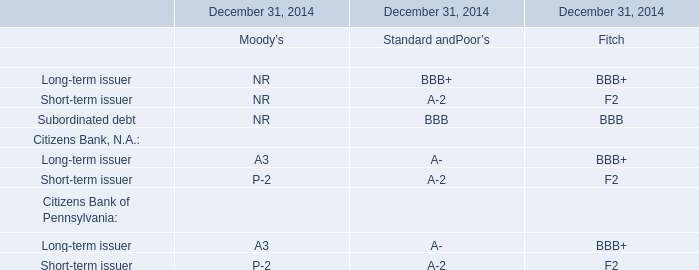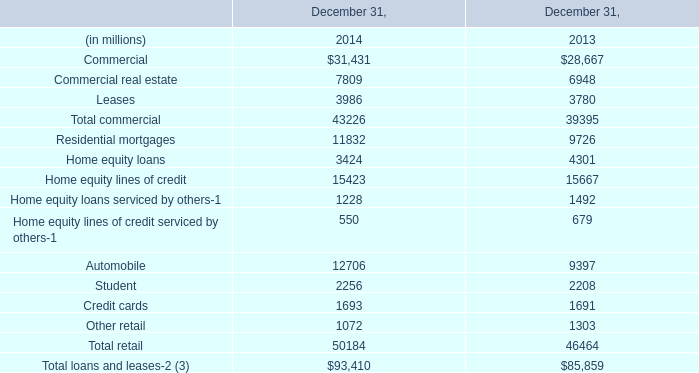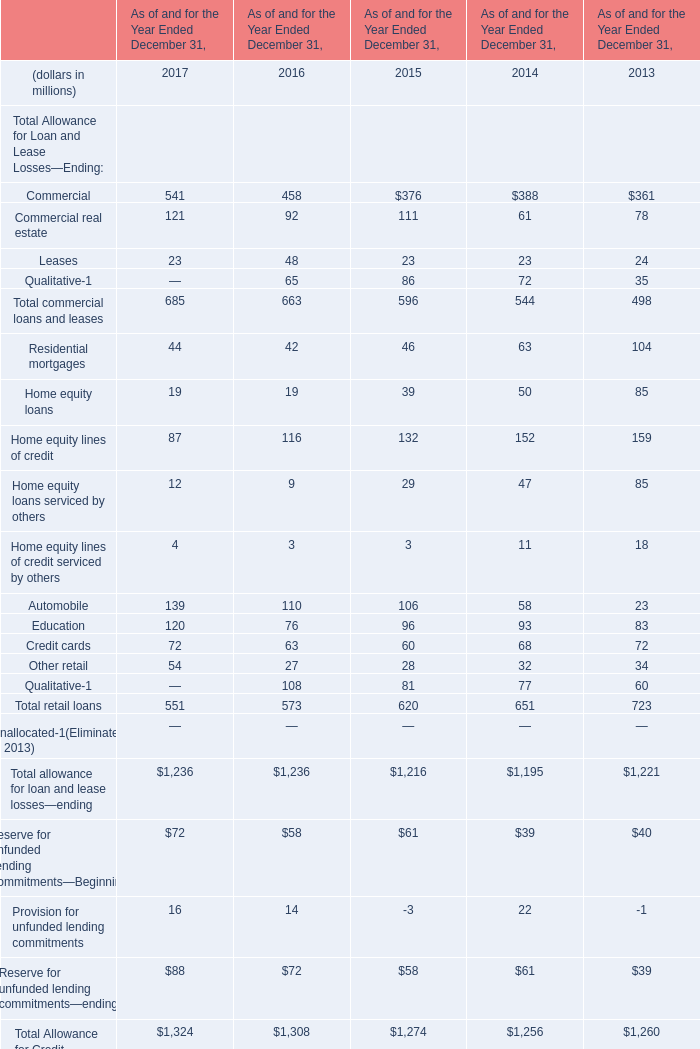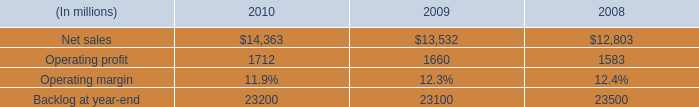What's the sum of Other retail of December 31, 2014, Net sales of 2008, and Residential mortgages of December 31, 2014 ? 
Computations: ((1072.0 + 12803.0) + 11832.0)
Answer: 25707.0. 